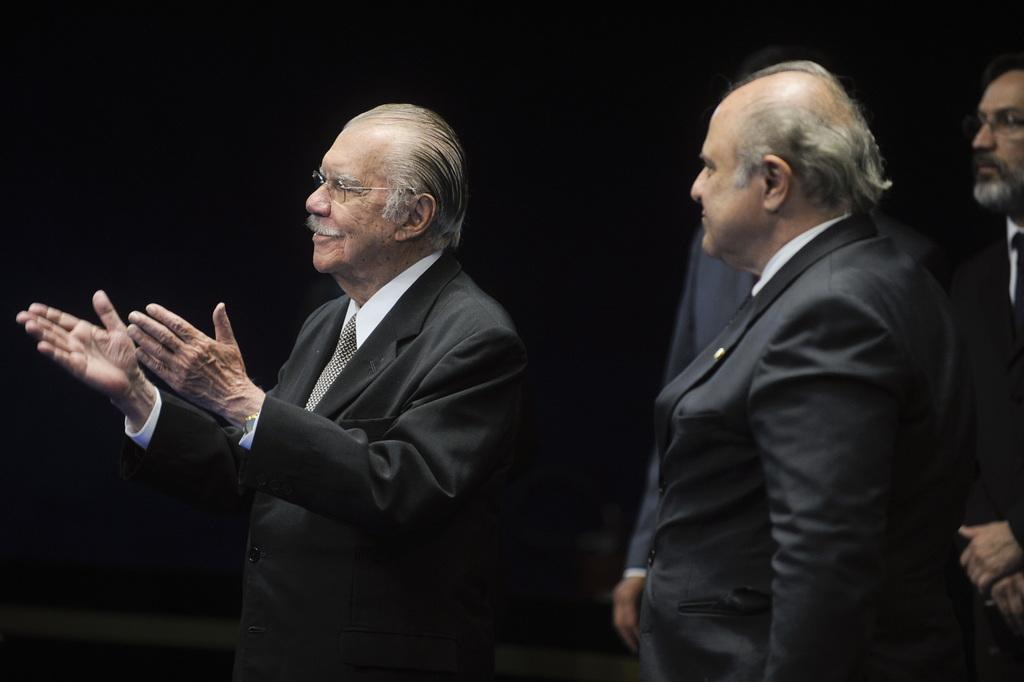How many people are in the image? There is a group of persons in the image. What are the people in the group wearing? The people in the group are wearing coats. What surface are the people standing on? The people in the group are standing on the floor. Where is the vase located in the image? There is no vase present in the image. What season is depicted in the image? The provided facts do not mention any seasonal details, so it cannot be determined from the image. 